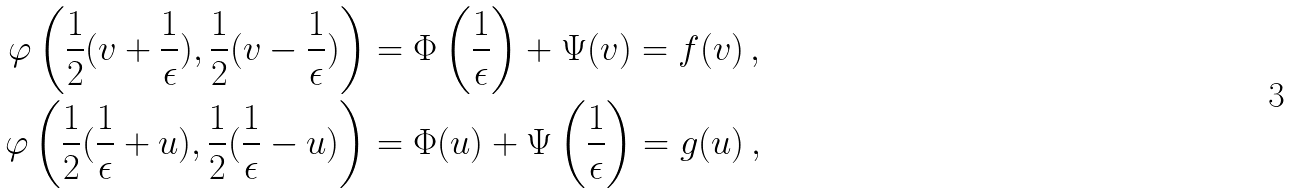<formula> <loc_0><loc_0><loc_500><loc_500>\varphi \left ( \frac { 1 } { 2 } ( v + \frac { 1 } { \epsilon } ) , \frac { 1 } { 2 } ( v - \frac { 1 } { \epsilon } ) \right ) & = \Phi \left ( \frac { 1 } { \epsilon } \right ) + \Psi ( v ) = f ( v ) \, , \\ \varphi \left ( \frac { 1 } { 2 } ( \frac { 1 } { \epsilon } + u ) , \frac { 1 } { 2 } ( \frac { 1 } { \epsilon } - u ) \right ) & = \Phi ( u ) + \Psi \left ( \frac { 1 } { \epsilon } \right ) = g ( u ) \, ,</formula> 